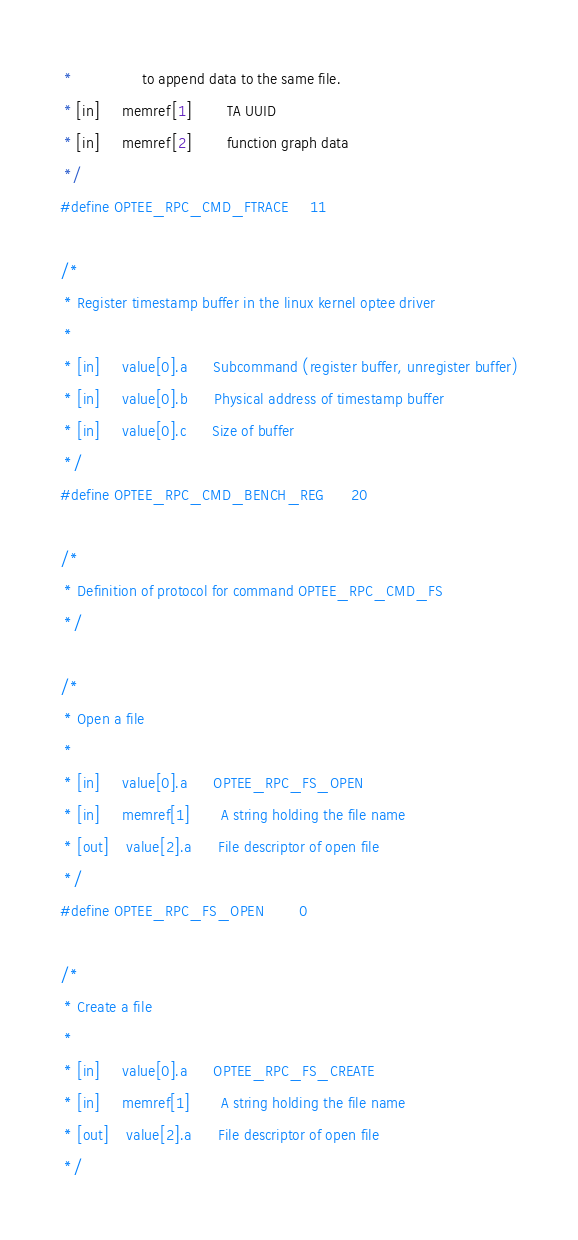Convert code to text. <code><loc_0><loc_0><loc_500><loc_500><_C_> *			    to append data to the same file.
 * [in]     memref[1]	    TA UUID
 * [in]     memref[2]	    function graph data
 */
#define OPTEE_RPC_CMD_FTRACE		11

/*
 * Register timestamp buffer in the linux kernel optee driver
 *
 * [in]     value[0].a	    Subcommand (register buffer, unregister buffer)
 * [in]     value[0].b	    Physical address of timestamp buffer
 * [in]     value[0].c	    Size of buffer
 */
#define OPTEE_RPC_CMD_BENCH_REG		20

/*
 * Definition of protocol for command OPTEE_RPC_CMD_FS
 */

/*
 * Open a file
 *
 * [in]     value[0].a	    OPTEE_RPC_FS_OPEN
 * [in]     memref[1]	    A string holding the file name
 * [out]    value[2].a	    File descriptor of open file
 */
#define OPTEE_RPC_FS_OPEN		0

/*
 * Create a file
 *
 * [in]     value[0].a	    OPTEE_RPC_FS_CREATE
 * [in]     memref[1]	    A string holding the file name
 * [out]    value[2].a	    File descriptor of open file
 */</code> 